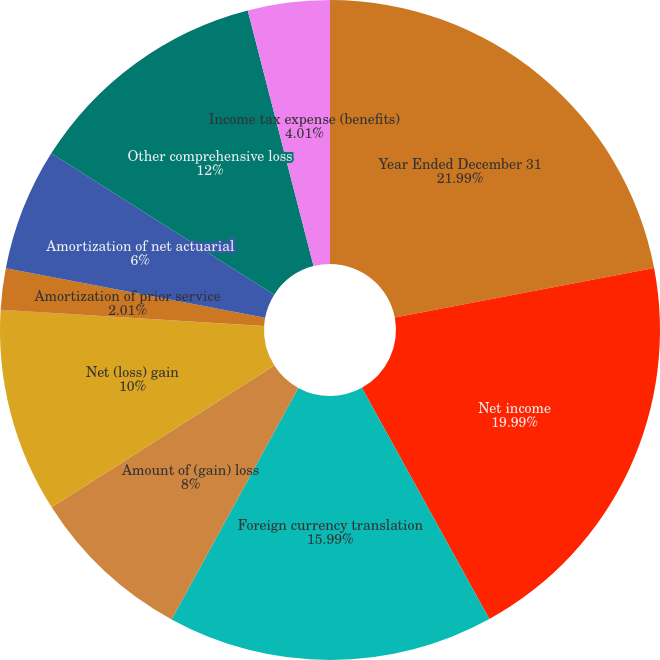<chart> <loc_0><loc_0><loc_500><loc_500><pie_chart><fcel>Year Ended December 31<fcel>Net income<fcel>Foreign currency translation<fcel>Amount of (gain) loss<fcel>Net (loss) gain<fcel>Prior service credit<fcel>Amortization of prior service<fcel>Amortization of net actuarial<fcel>Other comprehensive loss<fcel>Income tax expense (benefits)<nl><fcel>21.99%<fcel>19.99%<fcel>15.99%<fcel>8.0%<fcel>10.0%<fcel>0.01%<fcel>2.01%<fcel>6.0%<fcel>12.0%<fcel>4.01%<nl></chart> 